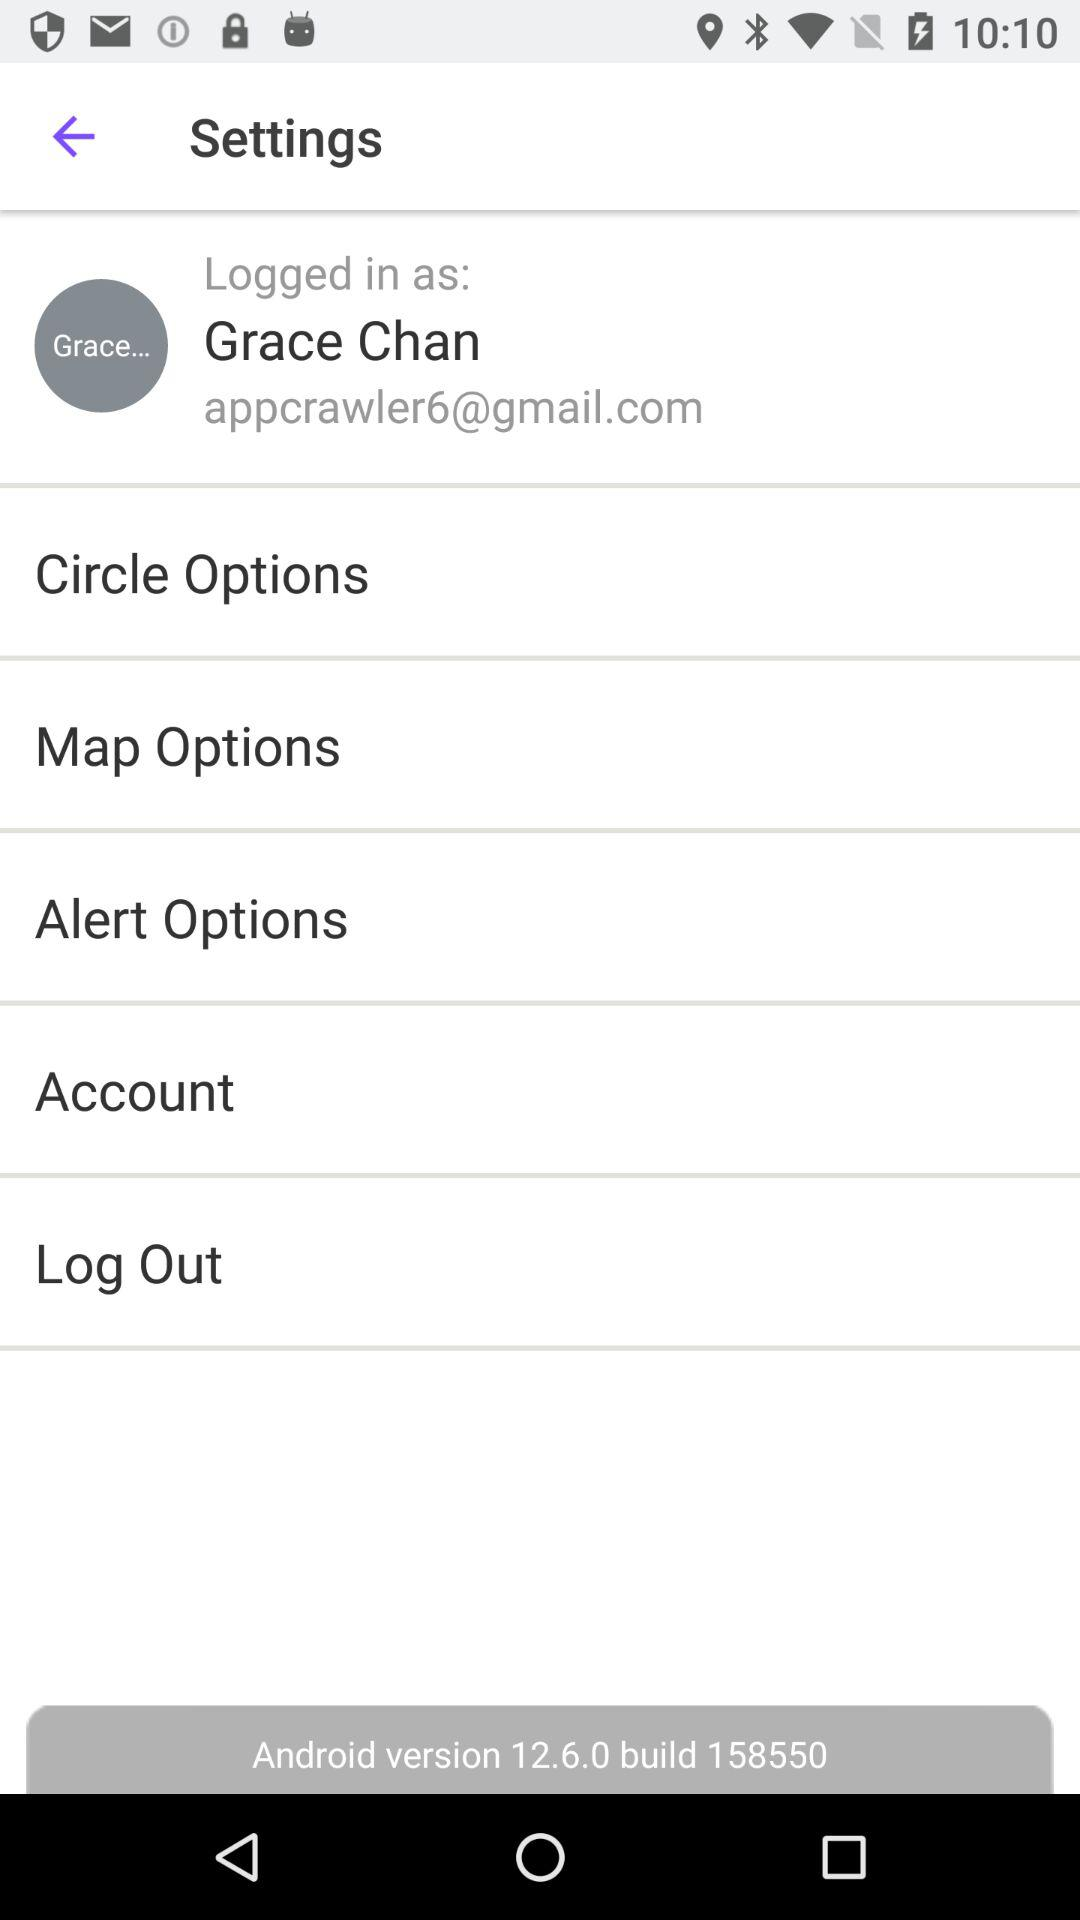What is the build number? The build number is 158550. 